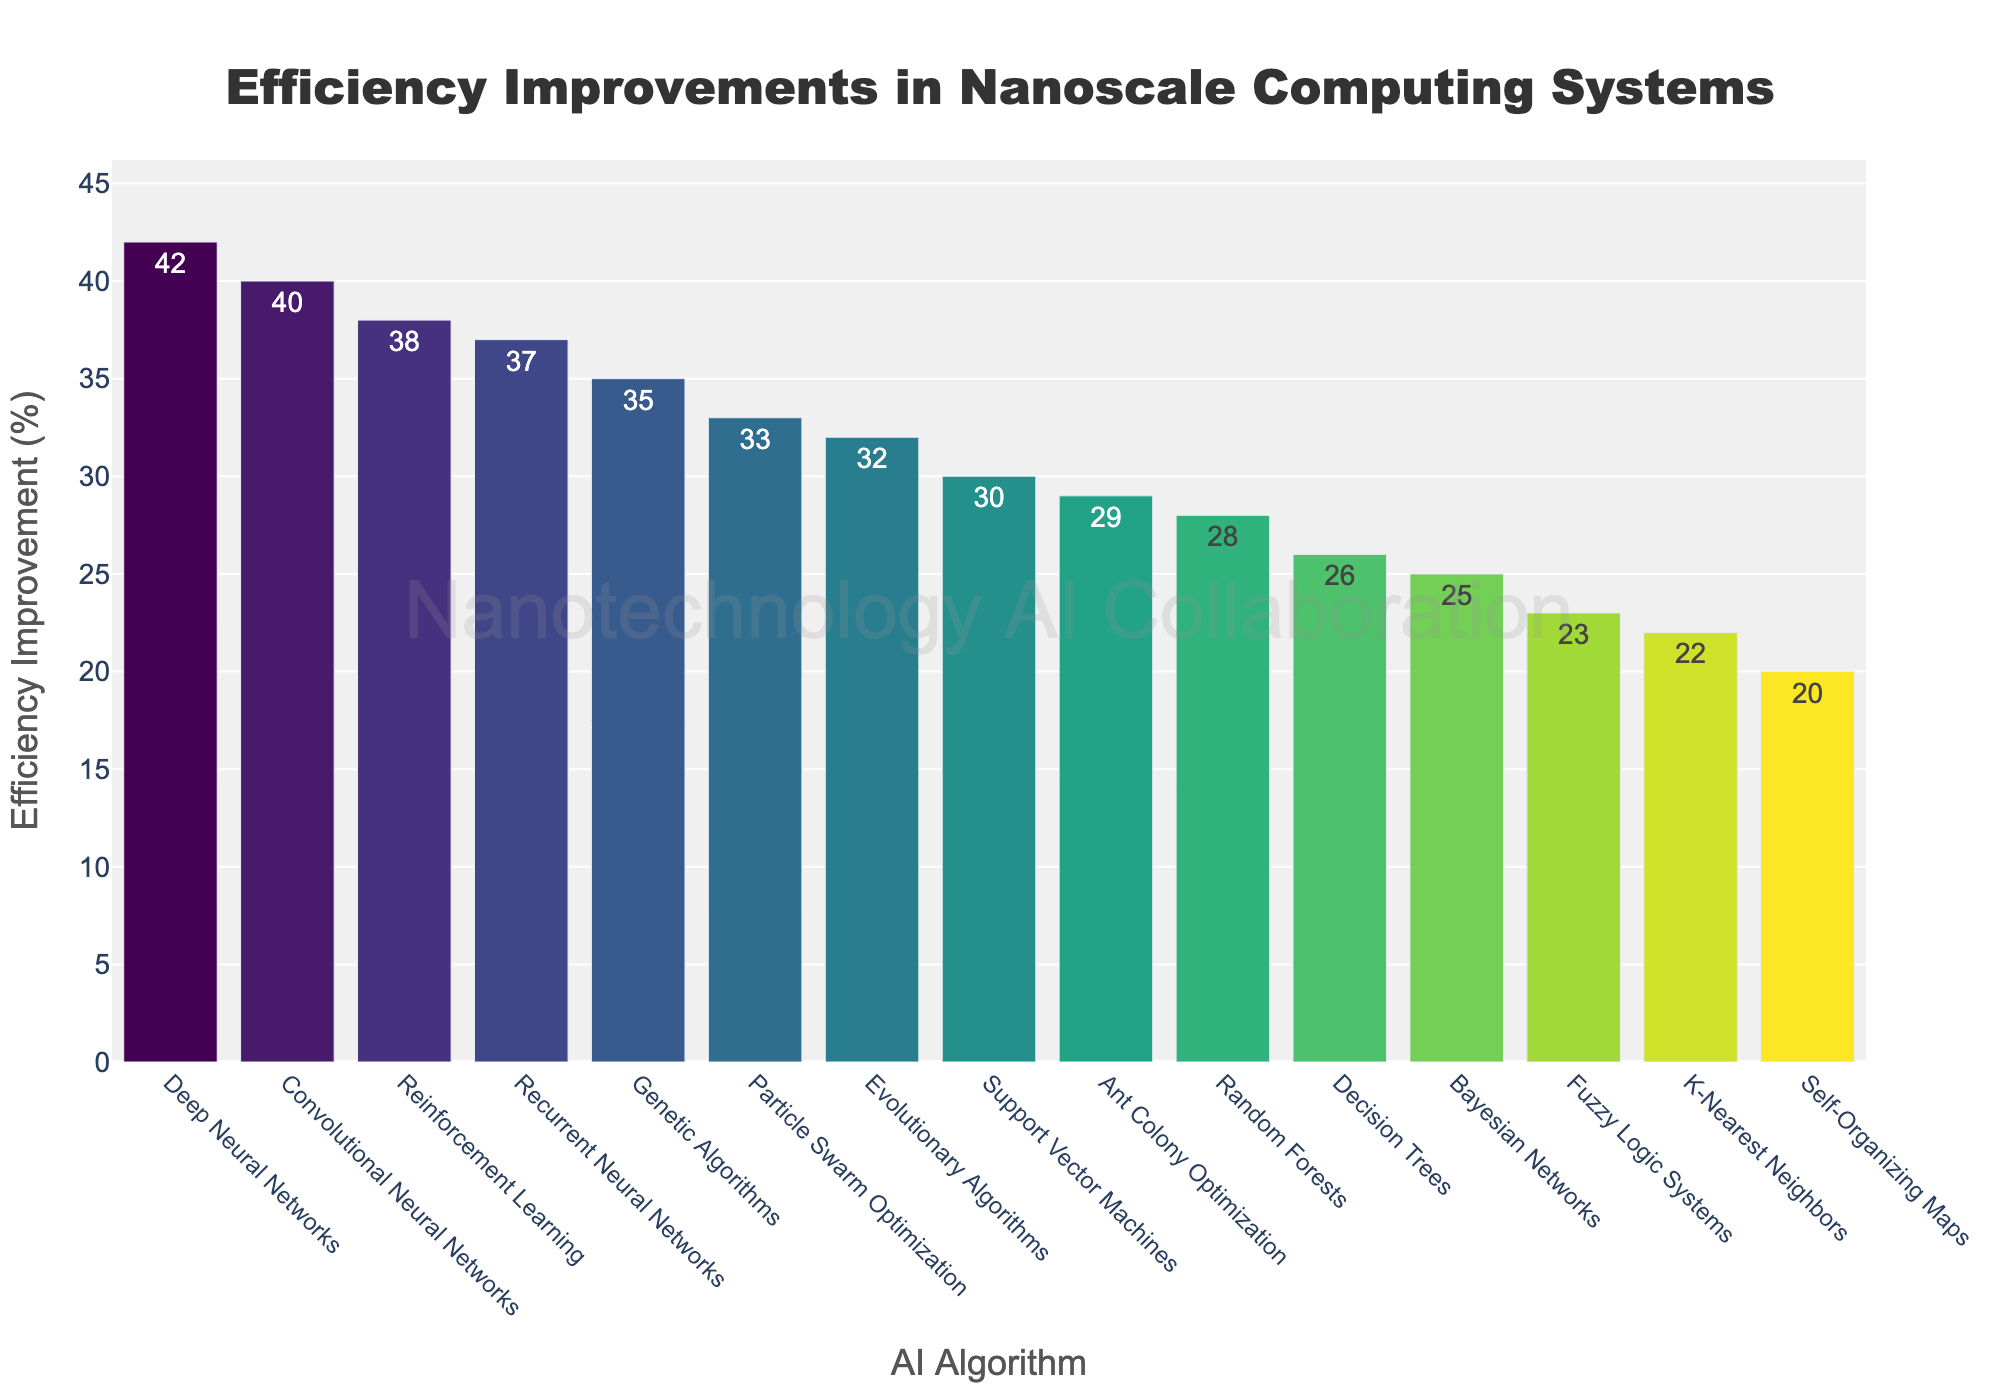What's the most efficient AI algorithm for nanoscale computing systems based on the data? The algorithm with the highest bar represents the greatest efficiency improvement. Deep Neural Networks has the highest bar with 42% efficiency improvement.
Answer: Deep Neural Networks Which AI algorithm has an efficiency improvement closest to 30%? Look for the bar closest to the 30% mark. Support Vector Machines has an efficiency improvement of 30%.
Answer: Support Vector Machines Which two algorithms have the smallest efficiency improvements? Identify the two shortest bars. Self-Organizing Maps and K-Nearest Neighbors have the smallest efficiency improvements with 20% and 22% respectively.
Answer: Self-Organizing Maps and K-Nearest Neighbors What's the difference in efficiency improvement between the highest and lowest performing algorithms? Subtract the efficiency improvement of the lowest performing algorithm from the highest. The difference between Deep Neural Networks (42%) and Self-Organizing Maps (20%) is 42% - 20% = 22%.
Answer: 22% How many algorithms have an efficiency improvement of 35% or higher? Count the number of bars at or above the 35% mark. Deep Neural Networks, Convolutional Neural Networks, Reinforcement Learning, Recurrent Neural Networks, and Genetic Algorithms have improvements of 35% or higher. That's 5 algorithms.
Answer: 5 What is the range of efficiency improvements for the algorithms? The range is the difference between the maximum and minimum values. The maximum improvement is 42% (Deep Neural Networks) and the minimum is 20% (Self-Organizing Maps), so the range is 42% - 20% = 22%.
Answer: 22% Which algorithm shows slightly higher efficiency than Decision Trees? Look for the bar right above Decision Trees. Ant Colony Optimization has an efficiency improvement of 29%, just above Decision Trees at 26%.
Answer: Ant Colony Optimization What is the sum of the efficiency improvements of the top three algorithms? Add the top three values. Deep Neural Networks (42%), Convolutional Neural Networks (40%), and Reinforcement Learning (38%) sum up to 42 + 40 + 38 = 120.
Answer: 120 Are there more algorithms with an efficiency improvement above or below 30%? Count the number of bars above and below the 30% mark. There are 8 bars above 30% and 7 bars below 30%.
Answer: Above 30% Do Bayesian Networks perform better than Fuzzy Logic Systems? Compare the height of their respective bars. Bayesian Networks have a 25% improvement while Fuzzy Logic Systems have 23%, so Bayesian Networks perform better.
Answer: Yes 